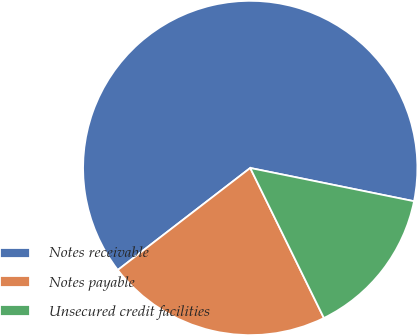<chart> <loc_0><loc_0><loc_500><loc_500><pie_chart><fcel>Notes receivable<fcel>Notes payable<fcel>Unsecured credit facilities<nl><fcel>63.64%<fcel>21.82%<fcel>14.55%<nl></chart> 